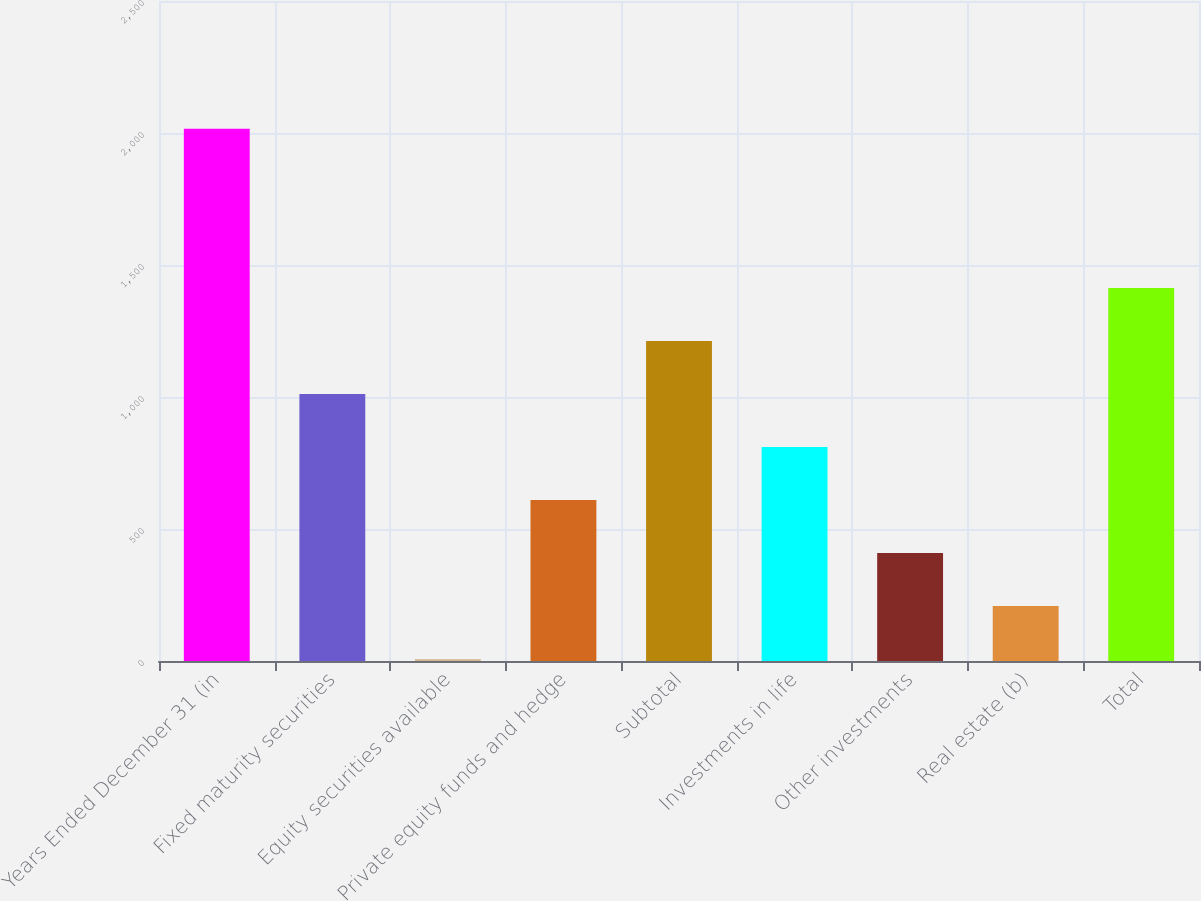Convert chart to OTSL. <chart><loc_0><loc_0><loc_500><loc_500><bar_chart><fcel>Years Ended December 31 (in<fcel>Fixed maturity securities<fcel>Equity securities available<fcel>Private equity funds and hedge<fcel>Subtotal<fcel>Investments in life<fcel>Other investments<fcel>Real estate (b)<fcel>Total<nl><fcel>2016<fcel>1011.5<fcel>7<fcel>609.7<fcel>1212.4<fcel>810.6<fcel>408.8<fcel>207.9<fcel>1413.3<nl></chart> 